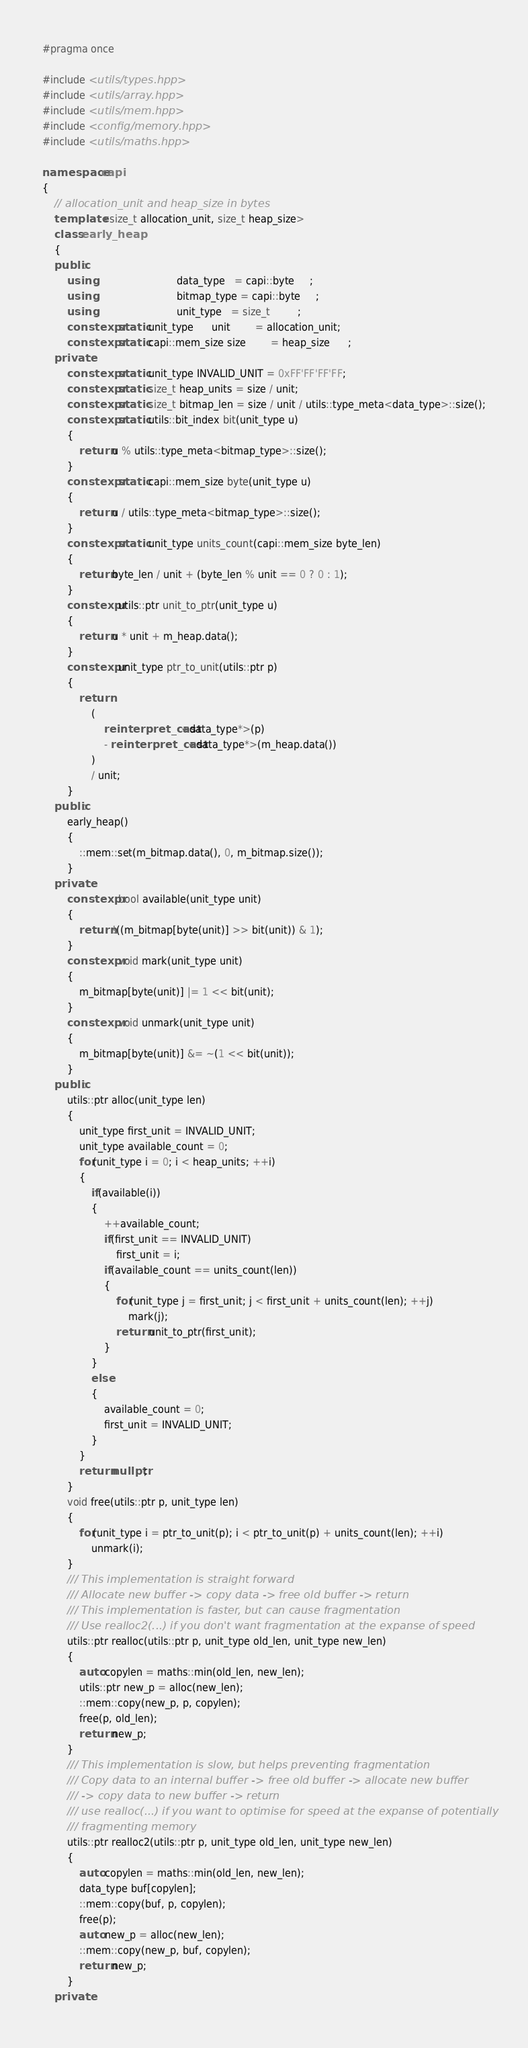Convert code to text. <code><loc_0><loc_0><loc_500><loc_500><_C++_>#pragma once

#include <utils/types.hpp>
#include <utils/array.hpp>
#include <utils/mem.hpp>
#include <config/memory.hpp>
#include <utils/maths.hpp>

namespace capi
{
    // allocation_unit and heap_size in bytes
    template <size_t allocation_unit, size_t heap_size>
    class early_heap
    {
    public:
        using                           data_type   = capi::byte     ;
        using                           bitmap_type = capi::byte     ;
        using                           unit_type   = size_t         ;
        constexpr static unit_type      unit        = allocation_unit;
        constexpr static capi::mem_size size        = heap_size      ;
    private:
        constexpr static unit_type INVALID_UNIT = 0xFF'FF'FF'FF;
        constexpr static size_t heap_units = size / unit;
        constexpr static size_t bitmap_len = size / unit / utils::type_meta<data_type>::size();
        constexpr static utils::bit_index bit(unit_type u)
        {
            return u % utils::type_meta<bitmap_type>::size();
        }
        constexpr static capi::mem_size byte(unit_type u)
        {
            return u / utils::type_meta<bitmap_type>::size();
        }
        constexpr static unit_type units_count(capi::mem_size byte_len)
        {
            return byte_len / unit + (byte_len % unit == 0 ? 0 : 1);
        }
        constexpr utils::ptr unit_to_ptr(unit_type u)
        {
            return u * unit + m_heap.data();
        }
        constexpr unit_type ptr_to_unit(utils::ptr p)
        {
            return 
                (
                    reinterpret_cast<data_type*>(p) 
                    - reinterpret_cast<data_type*>(m_heap.data())
                ) 
                / unit;
        }
    public:
        early_heap() 
        {
            ::mem::set(m_bitmap.data(), 0, m_bitmap.size());
        }
    private:
        constexpr bool available(unit_type unit)
        {
            return !((m_bitmap[byte(unit)] >> bit(unit)) & 1);
        }
        constexpr void mark(unit_type unit)
        {
            m_bitmap[byte(unit)] |= 1 << bit(unit);
        }
        constexpr void unmark(unit_type unit)
        {
            m_bitmap[byte(unit)] &= ~(1 << bit(unit));
        }
    public:
        utils::ptr alloc(unit_type len)
        {
            unit_type first_unit = INVALID_UNIT;
            unit_type available_count = 0;
            for(unit_type i = 0; i < heap_units; ++i)
            {
                if(available(i))
                {
                    ++available_count;
                    if(first_unit == INVALID_UNIT)
                        first_unit = i;
                    if(available_count == units_count(len))
                    {
                        for(unit_type j = first_unit; j < first_unit + units_count(len); ++j)
                            mark(j);
                        return unit_to_ptr(first_unit);
                    }
                }
                else
                {
                    available_count = 0;
                    first_unit = INVALID_UNIT;
                }
            }
            return nullptr;
        }
        void free(utils::ptr p, unit_type len)
        {
            for(unit_type i = ptr_to_unit(p); i < ptr_to_unit(p) + units_count(len); ++i)
                unmark(i);
        }
        /// This implementation is straight forward
        /// Allocate new buffer -> copy data -> free old buffer -> return
        /// This implementation is faster, but can cause fragmentation
        /// Use realloc2(...) if you don't want fragmentation at the expanse of speed
        utils::ptr realloc(utils::ptr p, unit_type old_len, unit_type new_len)
        {
            auto copylen = maths::min(old_len, new_len);
            utils::ptr new_p = alloc(new_len);
            ::mem::copy(new_p, p, copylen);
            free(p, old_len);
            return new_p;
        }
        /// This implementation is slow, but helps preventing fragmentation
        /// Copy data to an internal buffer -> free old buffer -> allocate new buffer
        /// -> copy data to new buffer -> return
        /// use realloc(...) if you want to optimise for speed at the expanse of potentially
        /// fragmenting memory
        utils::ptr realloc2(utils::ptr p, unit_type old_len, unit_type new_len)
        {
            auto copylen = maths::min(old_len, new_len);
            data_type buf[copylen];
            ::mem::copy(buf, p, copylen);
            free(p);
            auto new_p = alloc(new_len);
            ::mem::copy(new_p, buf, copylen);
            return new_p;
        }
    private:</code> 